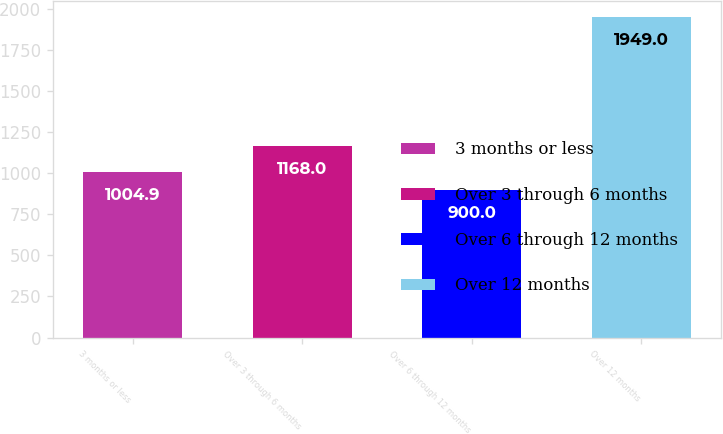Convert chart to OTSL. <chart><loc_0><loc_0><loc_500><loc_500><bar_chart><fcel>3 months or less<fcel>Over 3 through 6 months<fcel>Over 6 through 12 months<fcel>Over 12 months<nl><fcel>1004.9<fcel>1168<fcel>900<fcel>1949<nl></chart> 